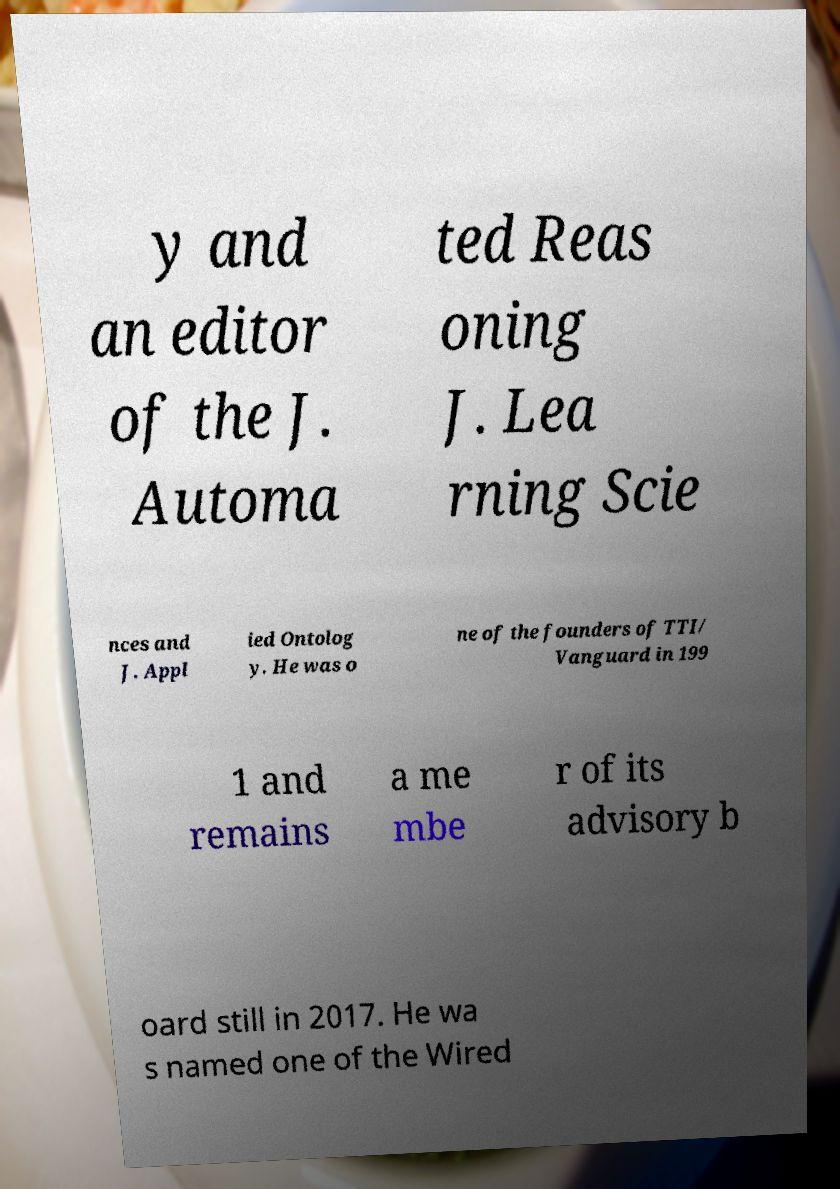Please read and relay the text visible in this image. What does it say? y and an editor of the J. Automa ted Reas oning J. Lea rning Scie nces and J. Appl ied Ontolog y. He was o ne of the founders of TTI/ Vanguard in 199 1 and remains a me mbe r of its advisory b oard still in 2017. He wa s named one of the Wired 